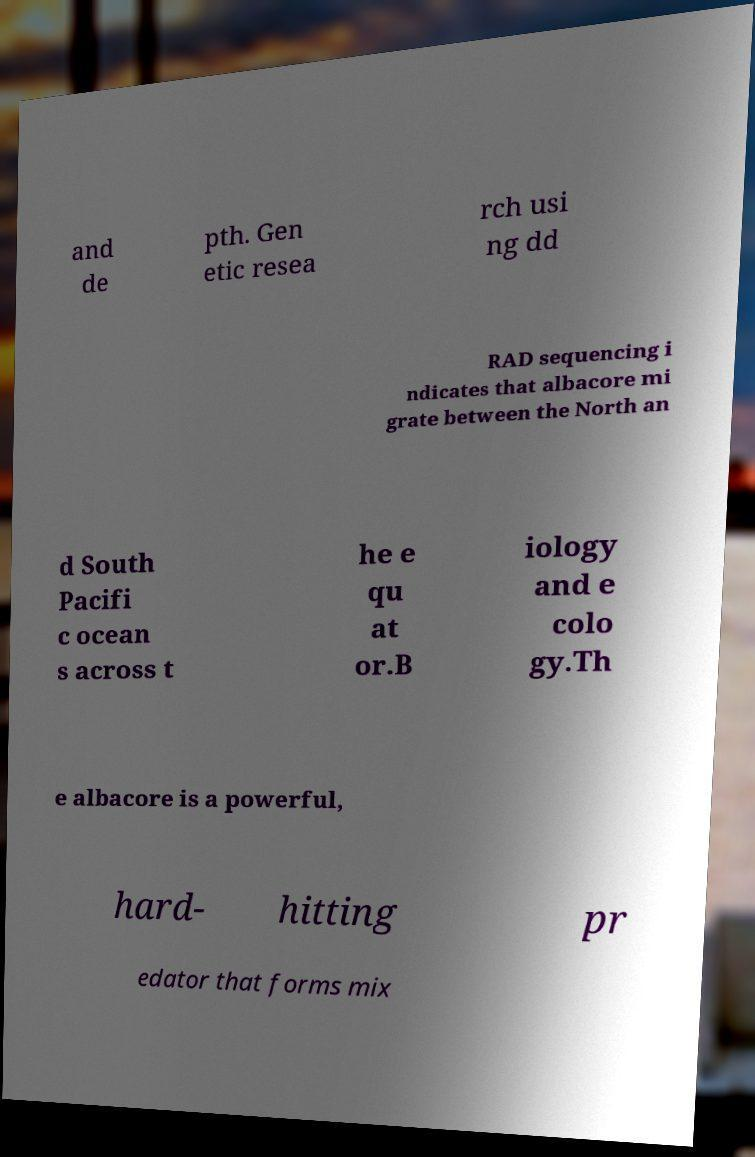I need the written content from this picture converted into text. Can you do that? and de pth. Gen etic resea rch usi ng dd RAD sequencing i ndicates that albacore mi grate between the North an d South Pacifi c ocean s across t he e qu at or.B iology and e colo gy.Th e albacore is a powerful, hard- hitting pr edator that forms mix 